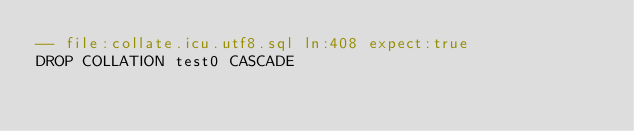<code> <loc_0><loc_0><loc_500><loc_500><_SQL_>-- file:collate.icu.utf8.sql ln:408 expect:true
DROP COLLATION test0 CASCADE
</code> 